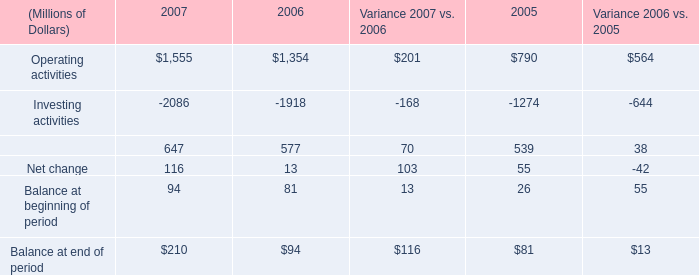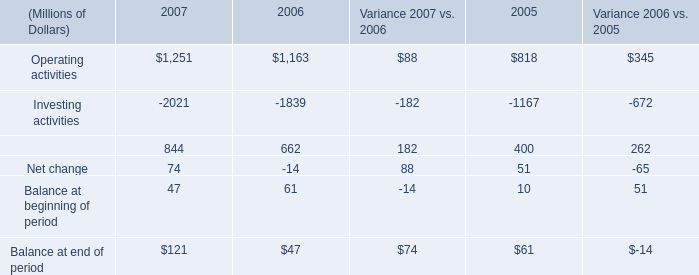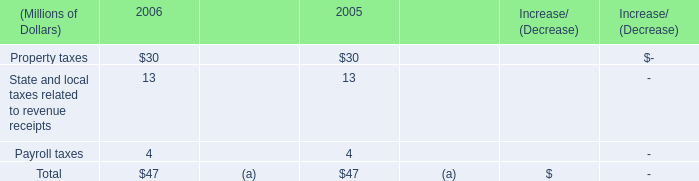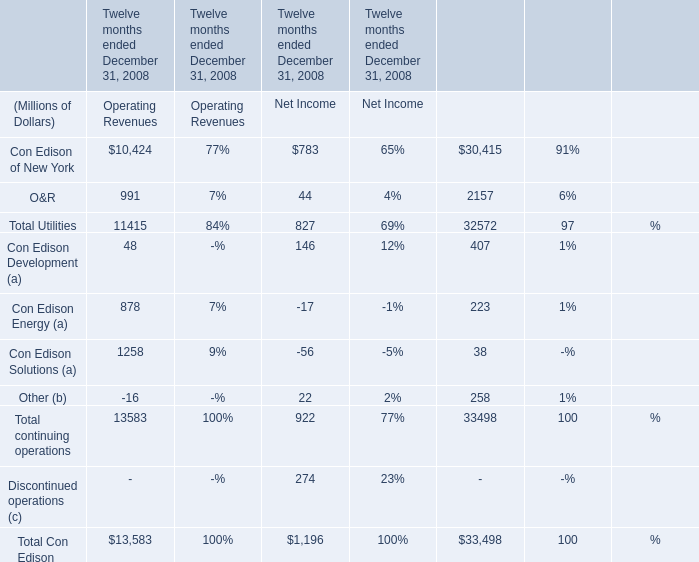What's the sum of Operating activities of 2007, and Investing activities of 2007 ? 
Computations: (1555.0 + 2021.0)
Answer: 3576.0. 